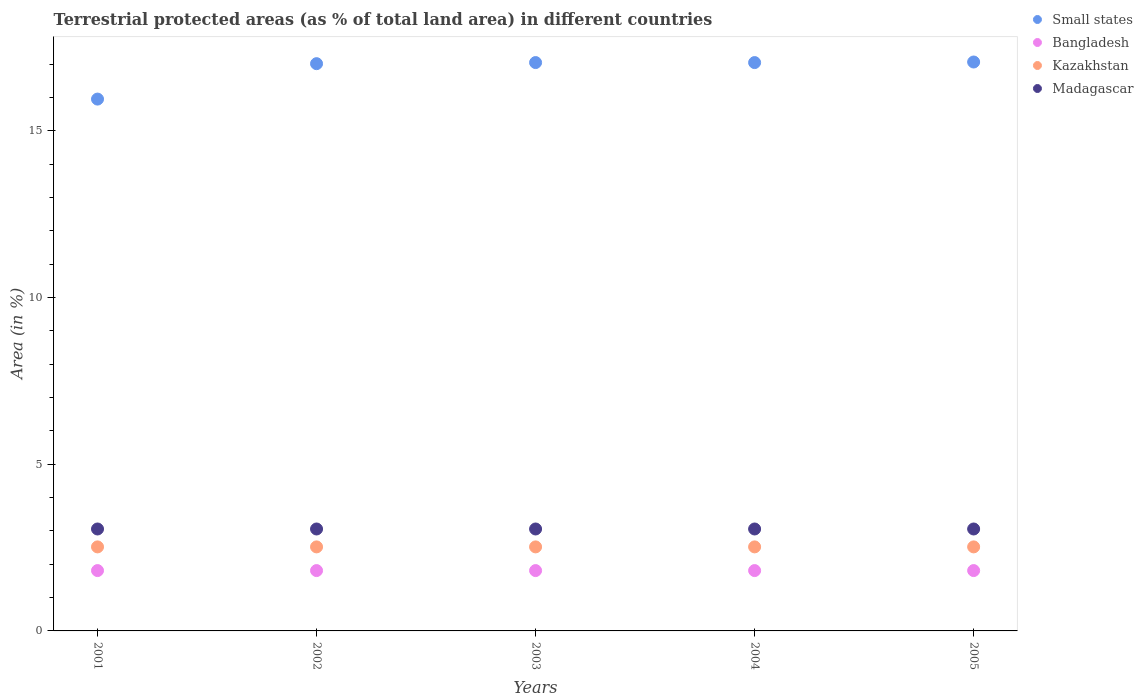How many different coloured dotlines are there?
Your response must be concise. 4. Is the number of dotlines equal to the number of legend labels?
Ensure brevity in your answer.  Yes. What is the percentage of terrestrial protected land in Kazakhstan in 2002?
Offer a very short reply. 2.52. Across all years, what is the maximum percentage of terrestrial protected land in Kazakhstan?
Give a very brief answer. 2.52. Across all years, what is the minimum percentage of terrestrial protected land in Bangladesh?
Make the answer very short. 1.81. In which year was the percentage of terrestrial protected land in Madagascar maximum?
Ensure brevity in your answer.  2001. What is the total percentage of terrestrial protected land in Kazakhstan in the graph?
Keep it short and to the point. 12.6. What is the difference between the percentage of terrestrial protected land in Bangladesh in 2004 and the percentage of terrestrial protected land in Kazakhstan in 2001?
Ensure brevity in your answer.  -0.71. What is the average percentage of terrestrial protected land in Madagascar per year?
Keep it short and to the point. 3.06. In the year 2005, what is the difference between the percentage of terrestrial protected land in Kazakhstan and percentage of terrestrial protected land in Bangladesh?
Your response must be concise. 0.71. In how many years, is the percentage of terrestrial protected land in Small states greater than 15 %?
Give a very brief answer. 5. Is the percentage of terrestrial protected land in Kazakhstan in 2003 less than that in 2004?
Your answer should be compact. No. Is the difference between the percentage of terrestrial protected land in Kazakhstan in 2002 and 2005 greater than the difference between the percentage of terrestrial protected land in Bangladesh in 2002 and 2005?
Offer a very short reply. No. What is the difference between the highest and the second highest percentage of terrestrial protected land in Small states?
Your answer should be compact. 0.02. What is the difference between the highest and the lowest percentage of terrestrial protected land in Bangladesh?
Your answer should be very brief. 0. Is the sum of the percentage of terrestrial protected land in Kazakhstan in 2002 and 2004 greater than the maximum percentage of terrestrial protected land in Madagascar across all years?
Keep it short and to the point. Yes. Is it the case that in every year, the sum of the percentage of terrestrial protected land in Madagascar and percentage of terrestrial protected land in Small states  is greater than the sum of percentage of terrestrial protected land in Kazakhstan and percentage of terrestrial protected land in Bangladesh?
Ensure brevity in your answer.  Yes. Is it the case that in every year, the sum of the percentage of terrestrial protected land in Madagascar and percentage of terrestrial protected land in Bangladesh  is greater than the percentage of terrestrial protected land in Small states?
Offer a very short reply. No. Does the percentage of terrestrial protected land in Bangladesh monotonically increase over the years?
Your answer should be very brief. No. How many dotlines are there?
Your answer should be compact. 4. What is the difference between two consecutive major ticks on the Y-axis?
Give a very brief answer. 5. Are the values on the major ticks of Y-axis written in scientific E-notation?
Provide a succinct answer. No. Does the graph contain grids?
Ensure brevity in your answer.  No. How many legend labels are there?
Provide a short and direct response. 4. What is the title of the graph?
Provide a short and direct response. Terrestrial protected areas (as % of total land area) in different countries. Does "Mali" appear as one of the legend labels in the graph?
Your answer should be very brief. No. What is the label or title of the Y-axis?
Your answer should be compact. Area (in %). What is the Area (in %) of Small states in 2001?
Provide a succinct answer. 15.95. What is the Area (in %) in Bangladesh in 2001?
Offer a very short reply. 1.81. What is the Area (in %) in Kazakhstan in 2001?
Make the answer very short. 2.52. What is the Area (in %) in Madagascar in 2001?
Your answer should be compact. 3.06. What is the Area (in %) of Small states in 2002?
Provide a succinct answer. 17.02. What is the Area (in %) in Bangladesh in 2002?
Your answer should be compact. 1.81. What is the Area (in %) of Kazakhstan in 2002?
Offer a terse response. 2.52. What is the Area (in %) of Madagascar in 2002?
Your answer should be very brief. 3.06. What is the Area (in %) of Small states in 2003?
Provide a short and direct response. 17.05. What is the Area (in %) of Bangladesh in 2003?
Your answer should be very brief. 1.81. What is the Area (in %) in Kazakhstan in 2003?
Offer a terse response. 2.52. What is the Area (in %) of Madagascar in 2003?
Provide a succinct answer. 3.06. What is the Area (in %) of Small states in 2004?
Provide a short and direct response. 17.05. What is the Area (in %) of Bangladesh in 2004?
Your answer should be compact. 1.81. What is the Area (in %) of Kazakhstan in 2004?
Give a very brief answer. 2.52. What is the Area (in %) in Madagascar in 2004?
Keep it short and to the point. 3.06. What is the Area (in %) in Small states in 2005?
Give a very brief answer. 17.07. What is the Area (in %) of Bangladesh in 2005?
Ensure brevity in your answer.  1.81. What is the Area (in %) of Kazakhstan in 2005?
Offer a very short reply. 2.52. What is the Area (in %) in Madagascar in 2005?
Provide a succinct answer. 3.06. Across all years, what is the maximum Area (in %) in Small states?
Provide a short and direct response. 17.07. Across all years, what is the maximum Area (in %) of Bangladesh?
Offer a very short reply. 1.81. Across all years, what is the maximum Area (in %) in Kazakhstan?
Offer a very short reply. 2.52. Across all years, what is the maximum Area (in %) in Madagascar?
Keep it short and to the point. 3.06. Across all years, what is the minimum Area (in %) of Small states?
Make the answer very short. 15.95. Across all years, what is the minimum Area (in %) of Bangladesh?
Provide a short and direct response. 1.81. Across all years, what is the minimum Area (in %) in Kazakhstan?
Provide a succinct answer. 2.52. Across all years, what is the minimum Area (in %) of Madagascar?
Your response must be concise. 3.06. What is the total Area (in %) in Small states in the graph?
Your answer should be compact. 84.13. What is the total Area (in %) of Bangladesh in the graph?
Give a very brief answer. 9.05. What is the total Area (in %) in Kazakhstan in the graph?
Provide a succinct answer. 12.6. What is the total Area (in %) in Madagascar in the graph?
Ensure brevity in your answer.  15.29. What is the difference between the Area (in %) of Small states in 2001 and that in 2002?
Offer a very short reply. -1.06. What is the difference between the Area (in %) of Kazakhstan in 2001 and that in 2002?
Ensure brevity in your answer.  0. What is the difference between the Area (in %) of Small states in 2001 and that in 2003?
Ensure brevity in your answer.  -1.1. What is the difference between the Area (in %) of Bangladesh in 2001 and that in 2003?
Provide a succinct answer. 0. What is the difference between the Area (in %) in Small states in 2001 and that in 2004?
Provide a short and direct response. -1.1. What is the difference between the Area (in %) of Bangladesh in 2001 and that in 2004?
Offer a very short reply. 0. What is the difference between the Area (in %) in Small states in 2001 and that in 2005?
Offer a very short reply. -1.11. What is the difference between the Area (in %) in Bangladesh in 2001 and that in 2005?
Ensure brevity in your answer.  0. What is the difference between the Area (in %) of Small states in 2002 and that in 2003?
Keep it short and to the point. -0.03. What is the difference between the Area (in %) of Small states in 2002 and that in 2004?
Your response must be concise. -0.03. What is the difference between the Area (in %) of Bangladesh in 2002 and that in 2004?
Keep it short and to the point. 0. What is the difference between the Area (in %) in Madagascar in 2002 and that in 2004?
Offer a very short reply. 0. What is the difference between the Area (in %) in Bangladesh in 2002 and that in 2005?
Your answer should be compact. 0. What is the difference between the Area (in %) of Kazakhstan in 2002 and that in 2005?
Provide a succinct answer. 0. What is the difference between the Area (in %) in Small states in 2003 and that in 2004?
Your response must be concise. 0. What is the difference between the Area (in %) in Bangladesh in 2003 and that in 2004?
Give a very brief answer. 0. What is the difference between the Area (in %) of Kazakhstan in 2003 and that in 2004?
Your answer should be compact. 0. What is the difference between the Area (in %) of Small states in 2003 and that in 2005?
Ensure brevity in your answer.  -0.02. What is the difference between the Area (in %) in Madagascar in 2003 and that in 2005?
Provide a succinct answer. 0. What is the difference between the Area (in %) in Small states in 2004 and that in 2005?
Offer a terse response. -0.02. What is the difference between the Area (in %) of Madagascar in 2004 and that in 2005?
Give a very brief answer. 0. What is the difference between the Area (in %) in Small states in 2001 and the Area (in %) in Bangladesh in 2002?
Provide a short and direct response. 14.14. What is the difference between the Area (in %) in Small states in 2001 and the Area (in %) in Kazakhstan in 2002?
Make the answer very short. 13.43. What is the difference between the Area (in %) in Small states in 2001 and the Area (in %) in Madagascar in 2002?
Ensure brevity in your answer.  12.9. What is the difference between the Area (in %) of Bangladesh in 2001 and the Area (in %) of Kazakhstan in 2002?
Keep it short and to the point. -0.71. What is the difference between the Area (in %) of Bangladesh in 2001 and the Area (in %) of Madagascar in 2002?
Keep it short and to the point. -1.25. What is the difference between the Area (in %) in Kazakhstan in 2001 and the Area (in %) in Madagascar in 2002?
Your answer should be very brief. -0.54. What is the difference between the Area (in %) of Small states in 2001 and the Area (in %) of Bangladesh in 2003?
Your answer should be compact. 14.14. What is the difference between the Area (in %) in Small states in 2001 and the Area (in %) in Kazakhstan in 2003?
Keep it short and to the point. 13.43. What is the difference between the Area (in %) of Small states in 2001 and the Area (in %) of Madagascar in 2003?
Offer a terse response. 12.9. What is the difference between the Area (in %) in Bangladesh in 2001 and the Area (in %) in Kazakhstan in 2003?
Your answer should be very brief. -0.71. What is the difference between the Area (in %) of Bangladesh in 2001 and the Area (in %) of Madagascar in 2003?
Give a very brief answer. -1.25. What is the difference between the Area (in %) in Kazakhstan in 2001 and the Area (in %) in Madagascar in 2003?
Provide a succinct answer. -0.54. What is the difference between the Area (in %) in Small states in 2001 and the Area (in %) in Bangladesh in 2004?
Keep it short and to the point. 14.14. What is the difference between the Area (in %) in Small states in 2001 and the Area (in %) in Kazakhstan in 2004?
Your answer should be very brief. 13.43. What is the difference between the Area (in %) in Small states in 2001 and the Area (in %) in Madagascar in 2004?
Your answer should be compact. 12.9. What is the difference between the Area (in %) of Bangladesh in 2001 and the Area (in %) of Kazakhstan in 2004?
Your answer should be very brief. -0.71. What is the difference between the Area (in %) of Bangladesh in 2001 and the Area (in %) of Madagascar in 2004?
Your answer should be very brief. -1.25. What is the difference between the Area (in %) in Kazakhstan in 2001 and the Area (in %) in Madagascar in 2004?
Offer a terse response. -0.54. What is the difference between the Area (in %) of Small states in 2001 and the Area (in %) of Bangladesh in 2005?
Ensure brevity in your answer.  14.14. What is the difference between the Area (in %) of Small states in 2001 and the Area (in %) of Kazakhstan in 2005?
Make the answer very short. 13.43. What is the difference between the Area (in %) of Small states in 2001 and the Area (in %) of Madagascar in 2005?
Give a very brief answer. 12.9. What is the difference between the Area (in %) of Bangladesh in 2001 and the Area (in %) of Kazakhstan in 2005?
Your response must be concise. -0.71. What is the difference between the Area (in %) of Bangladesh in 2001 and the Area (in %) of Madagascar in 2005?
Keep it short and to the point. -1.25. What is the difference between the Area (in %) in Kazakhstan in 2001 and the Area (in %) in Madagascar in 2005?
Your response must be concise. -0.54. What is the difference between the Area (in %) in Small states in 2002 and the Area (in %) in Bangladesh in 2003?
Provide a short and direct response. 15.21. What is the difference between the Area (in %) of Small states in 2002 and the Area (in %) of Kazakhstan in 2003?
Offer a very short reply. 14.49. What is the difference between the Area (in %) in Small states in 2002 and the Area (in %) in Madagascar in 2003?
Your answer should be very brief. 13.96. What is the difference between the Area (in %) in Bangladesh in 2002 and the Area (in %) in Kazakhstan in 2003?
Make the answer very short. -0.71. What is the difference between the Area (in %) of Bangladesh in 2002 and the Area (in %) of Madagascar in 2003?
Ensure brevity in your answer.  -1.25. What is the difference between the Area (in %) of Kazakhstan in 2002 and the Area (in %) of Madagascar in 2003?
Give a very brief answer. -0.54. What is the difference between the Area (in %) of Small states in 2002 and the Area (in %) of Bangladesh in 2004?
Provide a succinct answer. 15.21. What is the difference between the Area (in %) in Small states in 2002 and the Area (in %) in Kazakhstan in 2004?
Your answer should be compact. 14.49. What is the difference between the Area (in %) of Small states in 2002 and the Area (in %) of Madagascar in 2004?
Make the answer very short. 13.96. What is the difference between the Area (in %) in Bangladesh in 2002 and the Area (in %) in Kazakhstan in 2004?
Keep it short and to the point. -0.71. What is the difference between the Area (in %) of Bangladesh in 2002 and the Area (in %) of Madagascar in 2004?
Keep it short and to the point. -1.25. What is the difference between the Area (in %) of Kazakhstan in 2002 and the Area (in %) of Madagascar in 2004?
Make the answer very short. -0.54. What is the difference between the Area (in %) of Small states in 2002 and the Area (in %) of Bangladesh in 2005?
Offer a terse response. 15.21. What is the difference between the Area (in %) of Small states in 2002 and the Area (in %) of Kazakhstan in 2005?
Provide a short and direct response. 14.49. What is the difference between the Area (in %) of Small states in 2002 and the Area (in %) of Madagascar in 2005?
Give a very brief answer. 13.96. What is the difference between the Area (in %) of Bangladesh in 2002 and the Area (in %) of Kazakhstan in 2005?
Your response must be concise. -0.71. What is the difference between the Area (in %) of Bangladesh in 2002 and the Area (in %) of Madagascar in 2005?
Make the answer very short. -1.25. What is the difference between the Area (in %) of Kazakhstan in 2002 and the Area (in %) of Madagascar in 2005?
Provide a short and direct response. -0.54. What is the difference between the Area (in %) in Small states in 2003 and the Area (in %) in Bangladesh in 2004?
Offer a very short reply. 15.24. What is the difference between the Area (in %) of Small states in 2003 and the Area (in %) of Kazakhstan in 2004?
Provide a short and direct response. 14.53. What is the difference between the Area (in %) of Small states in 2003 and the Area (in %) of Madagascar in 2004?
Offer a terse response. 13.99. What is the difference between the Area (in %) of Bangladesh in 2003 and the Area (in %) of Kazakhstan in 2004?
Your answer should be very brief. -0.71. What is the difference between the Area (in %) in Bangladesh in 2003 and the Area (in %) in Madagascar in 2004?
Your answer should be compact. -1.25. What is the difference between the Area (in %) of Kazakhstan in 2003 and the Area (in %) of Madagascar in 2004?
Provide a short and direct response. -0.54. What is the difference between the Area (in %) in Small states in 2003 and the Area (in %) in Bangladesh in 2005?
Make the answer very short. 15.24. What is the difference between the Area (in %) in Small states in 2003 and the Area (in %) in Kazakhstan in 2005?
Keep it short and to the point. 14.53. What is the difference between the Area (in %) of Small states in 2003 and the Area (in %) of Madagascar in 2005?
Offer a terse response. 13.99. What is the difference between the Area (in %) in Bangladesh in 2003 and the Area (in %) in Kazakhstan in 2005?
Offer a terse response. -0.71. What is the difference between the Area (in %) in Bangladesh in 2003 and the Area (in %) in Madagascar in 2005?
Your response must be concise. -1.25. What is the difference between the Area (in %) of Kazakhstan in 2003 and the Area (in %) of Madagascar in 2005?
Make the answer very short. -0.54. What is the difference between the Area (in %) of Small states in 2004 and the Area (in %) of Bangladesh in 2005?
Make the answer very short. 15.24. What is the difference between the Area (in %) in Small states in 2004 and the Area (in %) in Kazakhstan in 2005?
Your answer should be very brief. 14.53. What is the difference between the Area (in %) in Small states in 2004 and the Area (in %) in Madagascar in 2005?
Offer a very short reply. 13.99. What is the difference between the Area (in %) in Bangladesh in 2004 and the Area (in %) in Kazakhstan in 2005?
Offer a terse response. -0.71. What is the difference between the Area (in %) in Bangladesh in 2004 and the Area (in %) in Madagascar in 2005?
Provide a short and direct response. -1.25. What is the difference between the Area (in %) of Kazakhstan in 2004 and the Area (in %) of Madagascar in 2005?
Provide a short and direct response. -0.54. What is the average Area (in %) of Small states per year?
Provide a short and direct response. 16.83. What is the average Area (in %) in Bangladesh per year?
Your response must be concise. 1.81. What is the average Area (in %) of Kazakhstan per year?
Provide a succinct answer. 2.52. What is the average Area (in %) of Madagascar per year?
Your answer should be very brief. 3.06. In the year 2001, what is the difference between the Area (in %) in Small states and Area (in %) in Bangladesh?
Provide a short and direct response. 14.14. In the year 2001, what is the difference between the Area (in %) of Small states and Area (in %) of Kazakhstan?
Give a very brief answer. 13.43. In the year 2001, what is the difference between the Area (in %) in Small states and Area (in %) in Madagascar?
Make the answer very short. 12.9. In the year 2001, what is the difference between the Area (in %) in Bangladesh and Area (in %) in Kazakhstan?
Your answer should be compact. -0.71. In the year 2001, what is the difference between the Area (in %) of Bangladesh and Area (in %) of Madagascar?
Offer a very short reply. -1.25. In the year 2001, what is the difference between the Area (in %) of Kazakhstan and Area (in %) of Madagascar?
Give a very brief answer. -0.54. In the year 2002, what is the difference between the Area (in %) in Small states and Area (in %) in Bangladesh?
Offer a very short reply. 15.21. In the year 2002, what is the difference between the Area (in %) in Small states and Area (in %) in Kazakhstan?
Ensure brevity in your answer.  14.49. In the year 2002, what is the difference between the Area (in %) in Small states and Area (in %) in Madagascar?
Offer a very short reply. 13.96. In the year 2002, what is the difference between the Area (in %) of Bangladesh and Area (in %) of Kazakhstan?
Provide a succinct answer. -0.71. In the year 2002, what is the difference between the Area (in %) of Bangladesh and Area (in %) of Madagascar?
Provide a short and direct response. -1.25. In the year 2002, what is the difference between the Area (in %) of Kazakhstan and Area (in %) of Madagascar?
Your answer should be very brief. -0.54. In the year 2003, what is the difference between the Area (in %) of Small states and Area (in %) of Bangladesh?
Give a very brief answer. 15.24. In the year 2003, what is the difference between the Area (in %) of Small states and Area (in %) of Kazakhstan?
Provide a short and direct response. 14.53. In the year 2003, what is the difference between the Area (in %) in Small states and Area (in %) in Madagascar?
Keep it short and to the point. 13.99. In the year 2003, what is the difference between the Area (in %) in Bangladesh and Area (in %) in Kazakhstan?
Provide a succinct answer. -0.71. In the year 2003, what is the difference between the Area (in %) of Bangladesh and Area (in %) of Madagascar?
Provide a succinct answer. -1.25. In the year 2003, what is the difference between the Area (in %) of Kazakhstan and Area (in %) of Madagascar?
Keep it short and to the point. -0.54. In the year 2004, what is the difference between the Area (in %) in Small states and Area (in %) in Bangladesh?
Your answer should be compact. 15.24. In the year 2004, what is the difference between the Area (in %) in Small states and Area (in %) in Kazakhstan?
Offer a very short reply. 14.53. In the year 2004, what is the difference between the Area (in %) of Small states and Area (in %) of Madagascar?
Your answer should be very brief. 13.99. In the year 2004, what is the difference between the Area (in %) of Bangladesh and Area (in %) of Kazakhstan?
Ensure brevity in your answer.  -0.71. In the year 2004, what is the difference between the Area (in %) in Bangladesh and Area (in %) in Madagascar?
Your response must be concise. -1.25. In the year 2004, what is the difference between the Area (in %) in Kazakhstan and Area (in %) in Madagascar?
Provide a short and direct response. -0.54. In the year 2005, what is the difference between the Area (in %) of Small states and Area (in %) of Bangladesh?
Offer a very short reply. 15.26. In the year 2005, what is the difference between the Area (in %) of Small states and Area (in %) of Kazakhstan?
Your response must be concise. 14.54. In the year 2005, what is the difference between the Area (in %) in Small states and Area (in %) in Madagascar?
Give a very brief answer. 14.01. In the year 2005, what is the difference between the Area (in %) in Bangladesh and Area (in %) in Kazakhstan?
Provide a short and direct response. -0.71. In the year 2005, what is the difference between the Area (in %) in Bangladesh and Area (in %) in Madagascar?
Keep it short and to the point. -1.25. In the year 2005, what is the difference between the Area (in %) of Kazakhstan and Area (in %) of Madagascar?
Give a very brief answer. -0.54. What is the ratio of the Area (in %) in Small states in 2001 to that in 2002?
Your answer should be very brief. 0.94. What is the ratio of the Area (in %) in Bangladesh in 2001 to that in 2002?
Give a very brief answer. 1. What is the ratio of the Area (in %) in Kazakhstan in 2001 to that in 2002?
Ensure brevity in your answer.  1. What is the ratio of the Area (in %) in Small states in 2001 to that in 2003?
Offer a terse response. 0.94. What is the ratio of the Area (in %) of Kazakhstan in 2001 to that in 2003?
Provide a short and direct response. 1. What is the ratio of the Area (in %) of Madagascar in 2001 to that in 2003?
Ensure brevity in your answer.  1. What is the ratio of the Area (in %) of Small states in 2001 to that in 2004?
Provide a succinct answer. 0.94. What is the ratio of the Area (in %) of Bangladesh in 2001 to that in 2004?
Your answer should be very brief. 1. What is the ratio of the Area (in %) in Madagascar in 2001 to that in 2004?
Give a very brief answer. 1. What is the ratio of the Area (in %) of Small states in 2001 to that in 2005?
Keep it short and to the point. 0.93. What is the ratio of the Area (in %) of Kazakhstan in 2001 to that in 2005?
Your answer should be compact. 1. What is the ratio of the Area (in %) in Madagascar in 2001 to that in 2005?
Your answer should be very brief. 1. What is the ratio of the Area (in %) of Kazakhstan in 2002 to that in 2003?
Provide a short and direct response. 1. What is the ratio of the Area (in %) in Small states in 2002 to that in 2004?
Make the answer very short. 1. What is the ratio of the Area (in %) of Bangladesh in 2002 to that in 2004?
Your response must be concise. 1. What is the ratio of the Area (in %) in Madagascar in 2002 to that in 2004?
Offer a very short reply. 1. What is the ratio of the Area (in %) in Small states in 2002 to that in 2005?
Keep it short and to the point. 1. What is the ratio of the Area (in %) of Kazakhstan in 2002 to that in 2005?
Offer a very short reply. 1. What is the ratio of the Area (in %) in Small states in 2003 to that in 2004?
Your answer should be very brief. 1. What is the ratio of the Area (in %) in Madagascar in 2003 to that in 2004?
Ensure brevity in your answer.  1. What is the ratio of the Area (in %) of Bangladesh in 2003 to that in 2005?
Ensure brevity in your answer.  1. What is the ratio of the Area (in %) of Madagascar in 2003 to that in 2005?
Make the answer very short. 1. What is the ratio of the Area (in %) in Bangladesh in 2004 to that in 2005?
Keep it short and to the point. 1. What is the ratio of the Area (in %) in Kazakhstan in 2004 to that in 2005?
Make the answer very short. 1. What is the difference between the highest and the second highest Area (in %) in Small states?
Give a very brief answer. 0.02. What is the difference between the highest and the second highest Area (in %) of Bangladesh?
Your response must be concise. 0. What is the difference between the highest and the second highest Area (in %) of Kazakhstan?
Give a very brief answer. 0. What is the difference between the highest and the lowest Area (in %) in Small states?
Provide a short and direct response. 1.11. What is the difference between the highest and the lowest Area (in %) of Bangladesh?
Offer a very short reply. 0. What is the difference between the highest and the lowest Area (in %) in Kazakhstan?
Your answer should be very brief. 0. What is the difference between the highest and the lowest Area (in %) of Madagascar?
Your response must be concise. 0. 